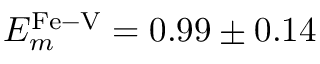<formula> <loc_0><loc_0><loc_500><loc_500>E _ { m } ^ { F e - V } = 0 . 9 9 \pm 0 . 1 4</formula> 